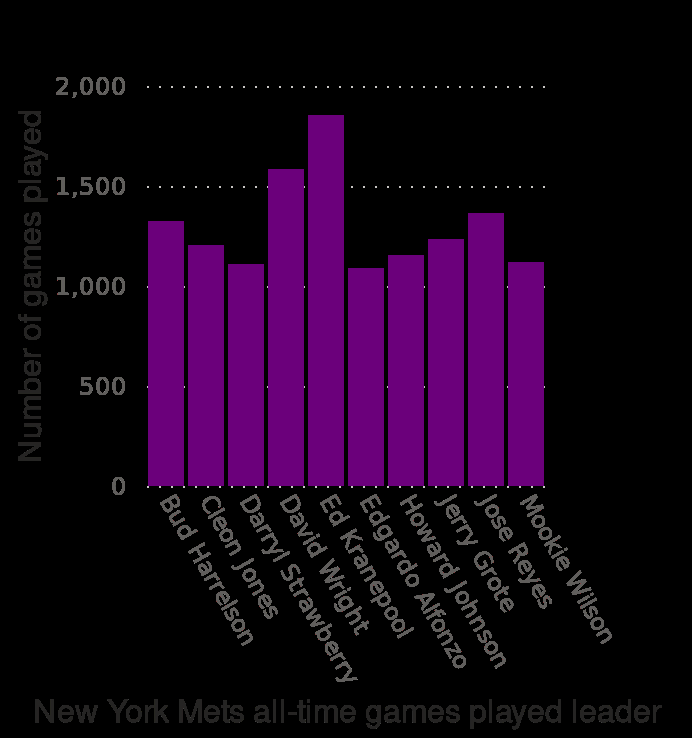<image>
Offer a thorough analysis of the image. Ed Kranepool led a large number a large number of New York games than the other players at around 1800, with David Wright closely behind at 1600. The lowest led games were by Edgardo Alfonzo at about 1100/. Who led the largest number of New York games?  Ed Kranepool led the largest number of New York games at around 1800. 